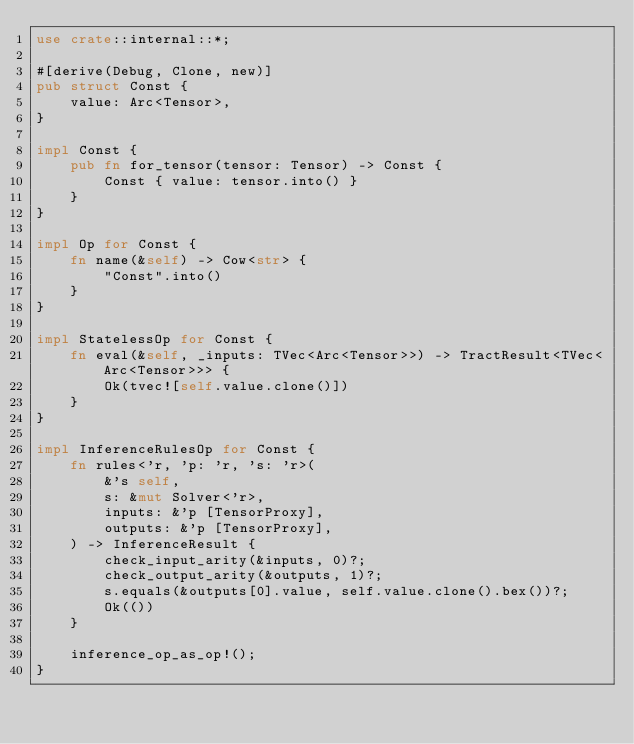<code> <loc_0><loc_0><loc_500><loc_500><_Rust_>use crate::internal::*;

#[derive(Debug, Clone, new)]
pub struct Const {
    value: Arc<Tensor>,
}

impl Const {
    pub fn for_tensor(tensor: Tensor) -> Const {
        Const { value: tensor.into() }
    }
}

impl Op for Const {
    fn name(&self) -> Cow<str> {
        "Const".into()
    }
}

impl StatelessOp for Const {
    fn eval(&self, _inputs: TVec<Arc<Tensor>>) -> TractResult<TVec<Arc<Tensor>>> {
        Ok(tvec![self.value.clone()])
    }
}

impl InferenceRulesOp for Const {
    fn rules<'r, 'p: 'r, 's: 'r>(
        &'s self,
        s: &mut Solver<'r>,
        inputs: &'p [TensorProxy],
        outputs: &'p [TensorProxy],
    ) -> InferenceResult {
        check_input_arity(&inputs, 0)?;
        check_output_arity(&outputs, 1)?;
        s.equals(&outputs[0].value, self.value.clone().bex())?;
        Ok(())
    }

    inference_op_as_op!();
}
</code> 